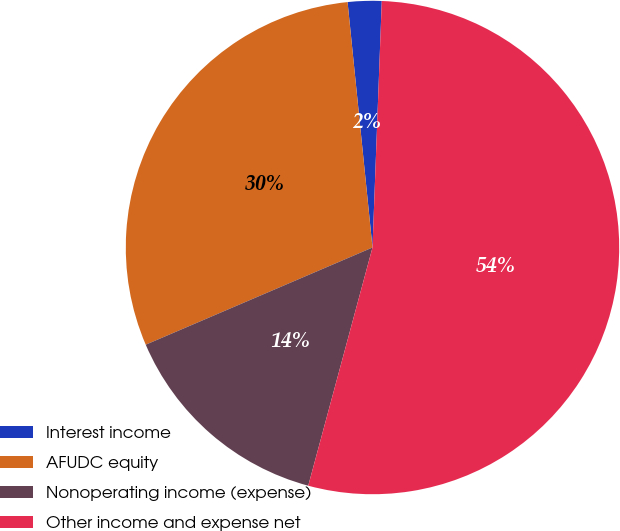<chart> <loc_0><loc_0><loc_500><loc_500><pie_chart><fcel>Interest income<fcel>AFUDC equity<fcel>Nonoperating income (expense)<fcel>Other income and expense net<nl><fcel>2.21%<fcel>29.83%<fcel>14.36%<fcel>53.59%<nl></chart> 